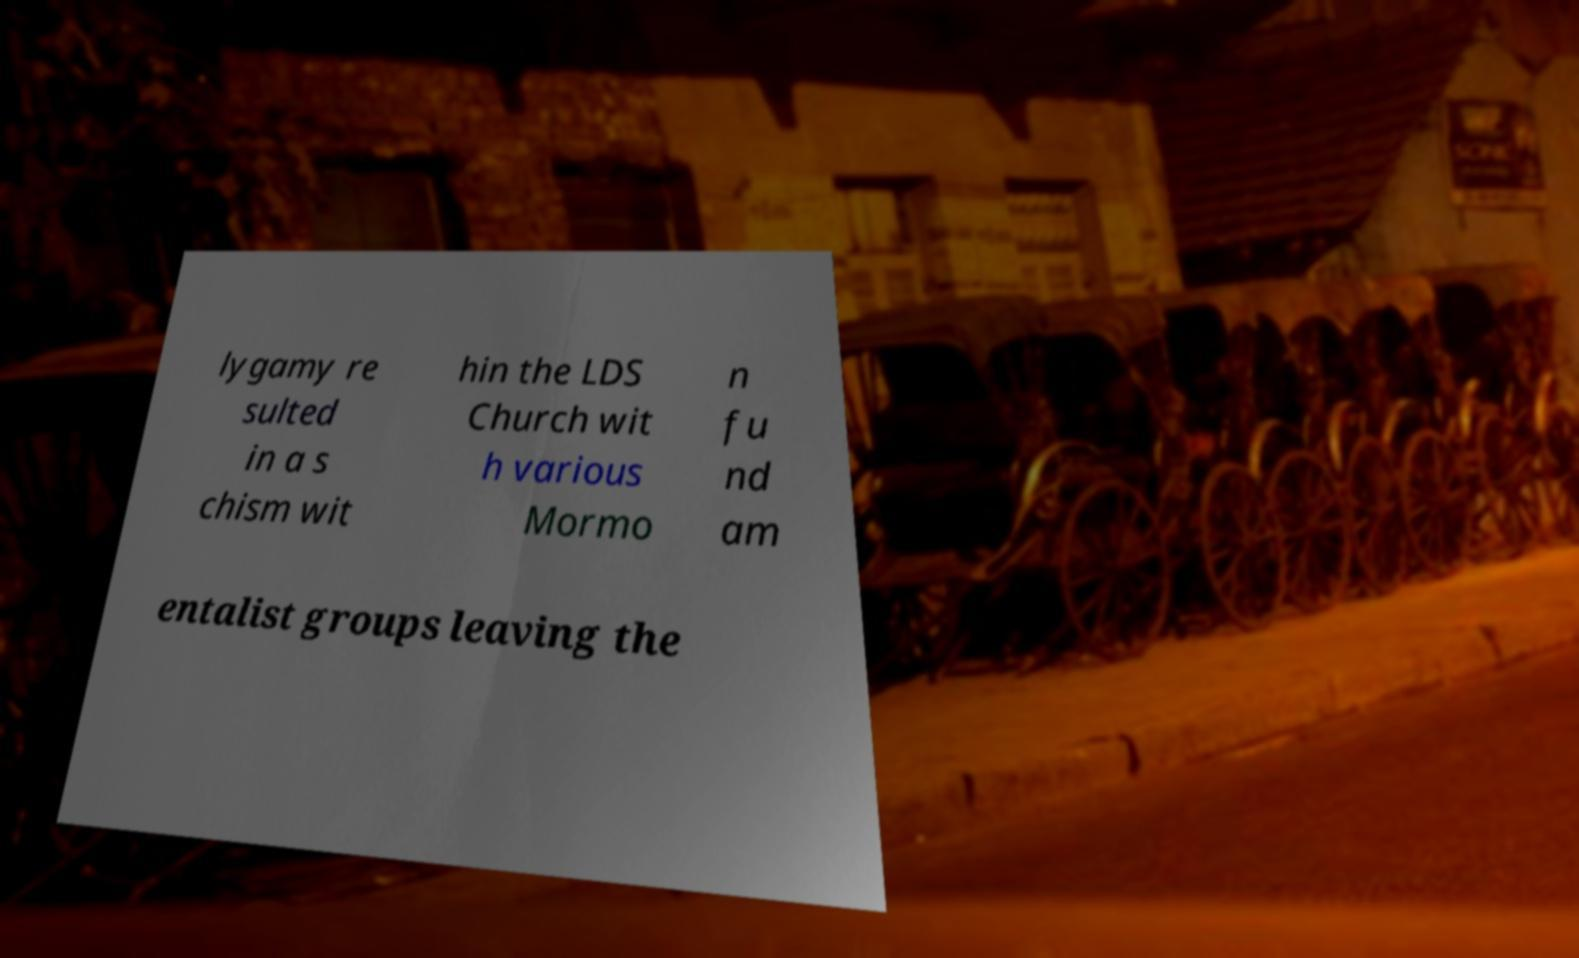I need the written content from this picture converted into text. Can you do that? lygamy re sulted in a s chism wit hin the LDS Church wit h various Mormo n fu nd am entalist groups leaving the 